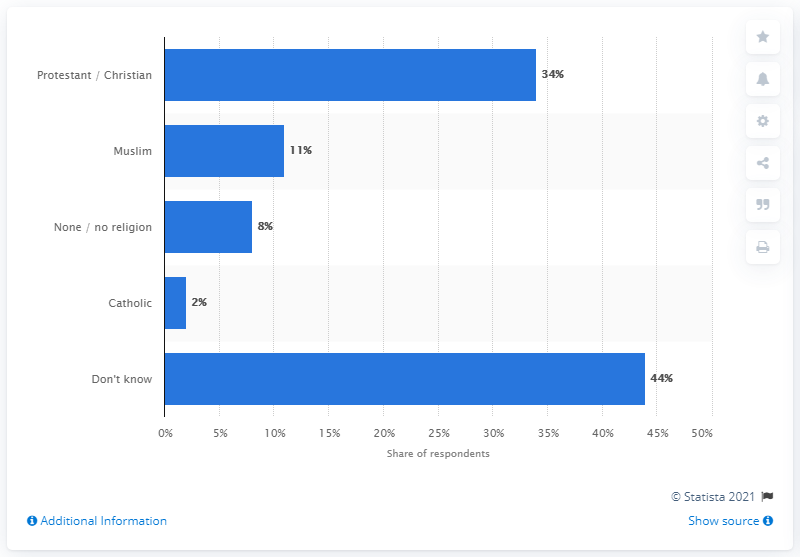Indicate a few pertinent items in this graphic. What is the Catholic percentage in the chart? It is 2%. In the chart, the sum of the highest and lowest values is 46. 